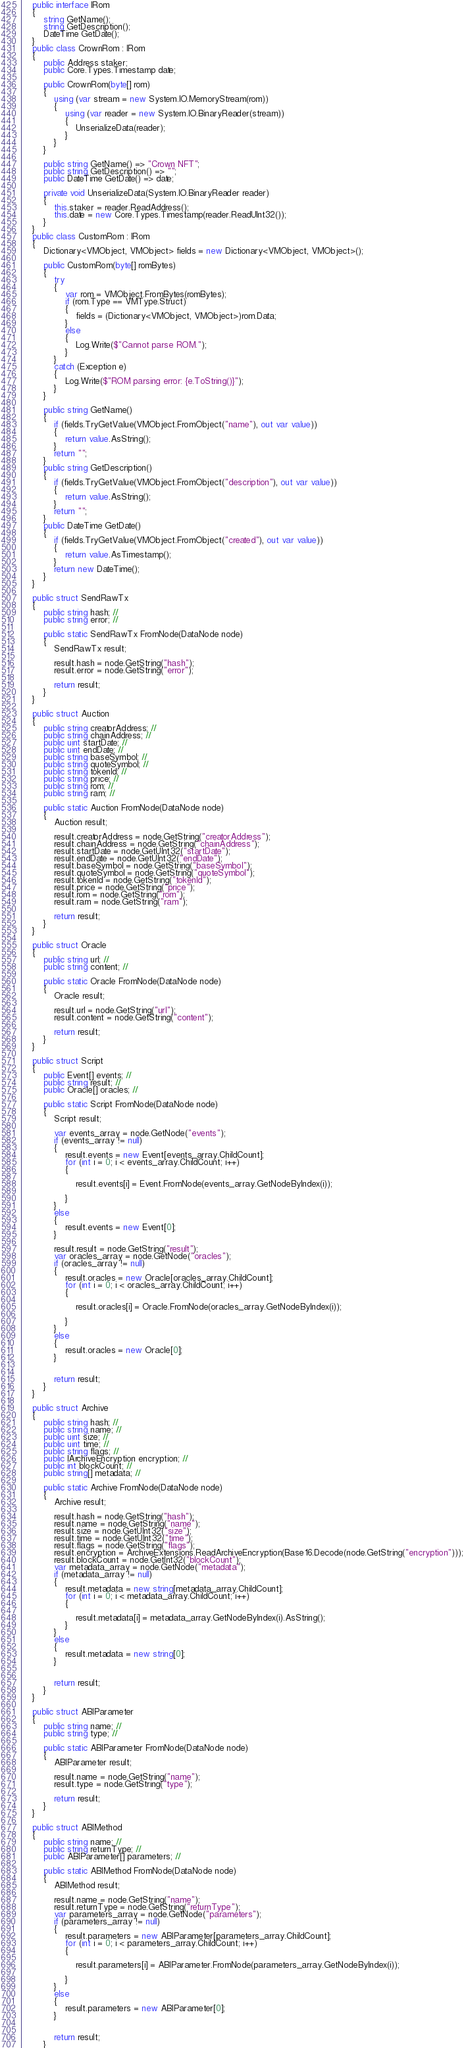<code> <loc_0><loc_0><loc_500><loc_500><_C#_>
    public interface IRom
    {
        string GetName();
        string GetDescription();
        DateTime GetDate();
    }
    public class CrownRom : IRom
    {
        public Address staker;
        public Core.Types.Timestamp date;

        public CrownRom(byte[] rom)
        {
            using (var stream = new System.IO.MemoryStream(rom))
            {
                using (var reader = new System.IO.BinaryReader(stream))
                {
                    UnserializeData(reader);
                }
            }
        }

        public string GetName() => "Crown NFT";
        public string GetDescription() => "";
        public DateTime GetDate() => date;

        private void UnserializeData(System.IO.BinaryReader reader)
        {
            this.staker = reader.ReadAddress();
            this.date = new Core.Types.Timestamp(reader.ReadUInt32());
        }
    }
    public class CustomRom : IRom
    {
        Dictionary<VMObject, VMObject> fields = new Dictionary<VMObject, VMObject>();

        public CustomRom(byte[] romBytes)
        {
            try
            {
                var rom = VMObject.FromBytes(romBytes);
                if (rom.Type == VMType.Struct)
                {
                    fields = (Dictionary<VMObject, VMObject>)rom.Data;
                }
                else
                {
                    Log.Write($"Cannot parse ROM.");
                }
            }
            catch (Exception e)
            {
                Log.Write($"ROM parsing error: {e.ToString()}");
            }
        }

        public string GetName()
        {
            if (fields.TryGetValue(VMObject.FromObject("name"), out var value))
            {
                return value.AsString();
            }
            return "";
        }
        public string GetDescription()
        {
            if (fields.TryGetValue(VMObject.FromObject("description"), out var value))
            {
                return value.AsString();
            }
            return "";
        }
        public DateTime GetDate()
        {
            if (fields.TryGetValue(VMObject.FromObject("created"), out var value))
            {
                return value.AsTimestamp();
            }
            return new DateTime();
        }
    }

    public struct SendRawTx
    {
        public string hash; //
        public string error; //

        public static SendRawTx FromNode(DataNode node)
        {
            SendRawTx result;

            result.hash = node.GetString("hash");
            result.error = node.GetString("error");

            return result;
        }
    }

    public struct Auction
    {
        public string creatorAddress; //
        public string chainAddress; //
        public uint startDate; //
        public uint endDate; //
        public string baseSymbol; //
        public string quoteSymbol; //
        public string tokenId; //
        public string price; //
        public string rom; //
        public string ram; //

        public static Auction FromNode(DataNode node)
        {
            Auction result;

            result.creatorAddress = node.GetString("creatorAddress");
            result.chainAddress = node.GetString("chainAddress");
            result.startDate = node.GetUInt32("startDate");
            result.endDate = node.GetUInt32("endDate");
            result.baseSymbol = node.GetString("baseSymbol");
            result.quoteSymbol = node.GetString("quoteSymbol");
            result.tokenId = node.GetString("tokenId");
            result.price = node.GetString("price");
            result.rom = node.GetString("rom");
            result.ram = node.GetString("ram");

            return result;
        }
    }

    public struct Oracle
    {
        public string url; //
        public string content; //

        public static Oracle FromNode(DataNode node)
        {
            Oracle result;

            result.url = node.GetString("url");
            result.content = node.GetString("content");

            return result;
        }
    }

    public struct Script
    {
        public Event[] events; //
        public string result; //
        public Oracle[] oracles; //

        public static Script FromNode(DataNode node)
        {
            Script result;

            var events_array = node.GetNode("events");
            if (events_array != null)
            {
                result.events = new Event[events_array.ChildCount];
                for (int i = 0; i < events_array.ChildCount; i++)
                {

                    result.events[i] = Event.FromNode(events_array.GetNodeByIndex(i));

                }
            }
            else
            {
                result.events = new Event[0];
            }

            result.result = node.GetString("result");
            var oracles_array = node.GetNode("oracles");
            if (oracles_array != null)
            {
                result.oracles = new Oracle[oracles_array.ChildCount];
                for (int i = 0; i < oracles_array.ChildCount; i++)
                {

                    result.oracles[i] = Oracle.FromNode(oracles_array.GetNodeByIndex(i));

                }
            }
            else
            {
                result.oracles = new Oracle[0];
            }


            return result;
        }
    }

    public struct Archive
    {
        public string hash; //
        public string name; //
        public uint size; //
        public uint time; //
        public string flags; //
        public IArchiveEncryption encryption; //
        public int blockCount; //
        public string[] metadata; //

        public static Archive FromNode(DataNode node)
        {
            Archive result;

            result.hash = node.GetString("hash");
            result.name = node.GetString("name");
            result.size = node.GetUInt32("size");
            result.time = node.GetUInt32("time");
            result.flags = node.GetString("flags");
            result.encryption = ArchiveExtensions.ReadArchiveEncryption(Base16.Decode(node.GetString("encryption")));
            result.blockCount = node.GetInt32("blockCount");
            var metadata_array = node.GetNode("metadata");
            if (metadata_array != null)
            {
                result.metadata = new string[metadata_array.ChildCount];
                for (int i = 0; i < metadata_array.ChildCount; i++)
                {

                    result.metadata[i] = metadata_array.GetNodeByIndex(i).AsString();
                }
            }
            else
            {
                result.metadata = new string[0];
            }


            return result;
        }
    }

    public struct ABIParameter
    {
        public string name; //
        public string type; //

        public static ABIParameter FromNode(DataNode node)
        {
            ABIParameter result;

            result.name = node.GetString("name");
            result.type = node.GetString("type");

            return result;
        }
    }

    public struct ABIMethod
    {
        public string name; //
        public string returnType; //
        public ABIParameter[] parameters; //

        public static ABIMethod FromNode(DataNode node)
        {
            ABIMethod result;

            result.name = node.GetString("name");
            result.returnType = node.GetString("returnType");
            var parameters_array = node.GetNode("parameters");
            if (parameters_array != null)
            {
                result.parameters = new ABIParameter[parameters_array.ChildCount];
                for (int i = 0; i < parameters_array.ChildCount; i++)
                {

                    result.parameters[i] = ABIParameter.FromNode(parameters_array.GetNodeByIndex(i));

                }
            }
            else
            {
                result.parameters = new ABIParameter[0];
            }


            return result;
        }</code> 